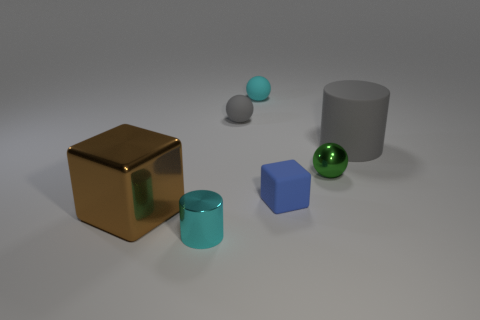There is a blue cube that is made of the same material as the big gray cylinder; what size is it?
Your response must be concise. Small. How many tiny objects have the same color as the rubber cylinder?
Provide a short and direct response. 1. Are any cyan cylinders visible?
Provide a succinct answer. Yes. There is a brown thing; does it have the same shape as the gray object that is behind the big cylinder?
Your answer should be very brief. No. There is a small metal object that is to the right of the cyan thing that is in front of the big cylinder that is behind the small green sphere; what is its color?
Provide a short and direct response. Green. There is a big shiny thing; are there any tiny cyan things to the right of it?
Your response must be concise. Yes. There is a matte sphere that is the same color as the tiny cylinder; what is its size?
Keep it short and to the point. Small. Is there a large yellow thing made of the same material as the gray ball?
Give a very brief answer. No. The matte block has what color?
Provide a short and direct response. Blue. Do the gray rubber thing that is to the right of the tiny cyan matte thing and the large brown shiny object have the same shape?
Offer a very short reply. No. 